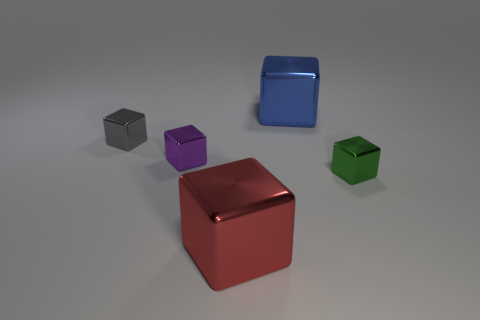There is a purple metal thing that is to the left of the blue shiny object; does it have the same shape as the red object?
Your answer should be very brief. Yes. How many big blue things have the same material as the tiny purple object?
Your answer should be compact. 1. How many things are things left of the green thing or small brown cylinders?
Your answer should be very brief. 4. What is the size of the red object?
Offer a very short reply. Large. What material is the big cube behind the large shiny block in front of the blue thing?
Provide a short and direct response. Metal. Do the metallic cube that is behind the gray shiny block and the green cube have the same size?
Make the answer very short. No. How many objects are tiny cubes that are behind the small green block or tiny shiny objects that are left of the green shiny block?
Your answer should be compact. 2. Are there fewer purple things that are in front of the small purple metal object than things left of the blue metal cube?
Offer a terse response. Yes. There is a thing that is both to the right of the purple metal object and behind the green metallic object; what is its size?
Ensure brevity in your answer.  Large. There is a purple metallic object that is the same size as the green metallic thing; what is its shape?
Keep it short and to the point. Cube. 